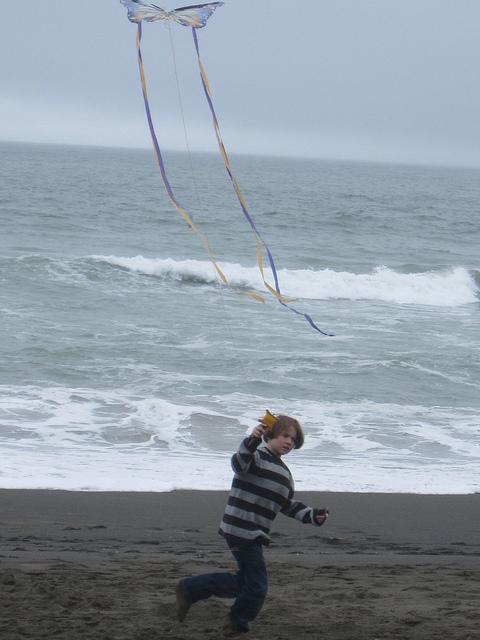Where is the kite?
Write a very short answer. Air. Does the wind look too strong for this kite?
Concise answer only. No. What color flippers is he wearing?
Answer briefly. Black. 